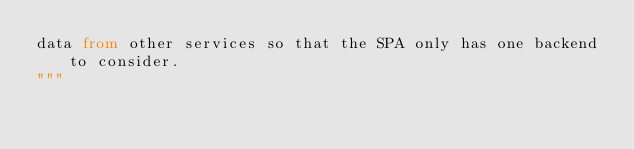Convert code to text. <code><loc_0><loc_0><loc_500><loc_500><_Python_>data from other services so that the SPA only has one backend to consider.
"""
</code> 